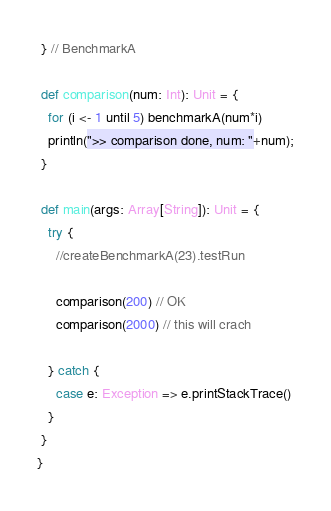<code> <loc_0><loc_0><loc_500><loc_500><_Scala_> } // BenchmarkA

 def comparison(num: Int): Unit = {
   for (i <- 1 until 5) benchmarkA(num*i)
   println(">> comparison done, num: "+num);
 }

 def main(args: Array[String]): Unit = {
   try {
     //createBenchmarkA(23).testRun

     comparison(200) // OK
     comparison(2000) // this will crach

   } catch {
     case e: Exception => e.printStackTrace()
   }
 }
}
</code> 